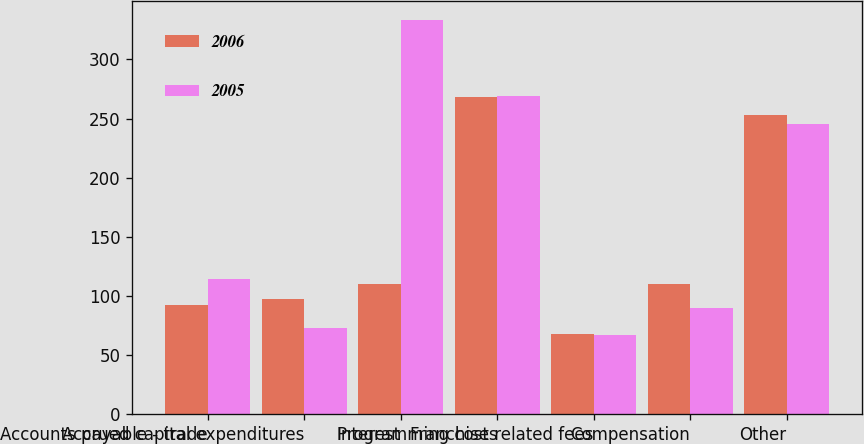<chart> <loc_0><loc_0><loc_500><loc_500><stacked_bar_chart><ecel><fcel>Accounts payable - trade<fcel>Accrued capital expenditures<fcel>Interest<fcel>Programming costs<fcel>Franchise related fees<fcel>Compensation<fcel>Other<nl><fcel>2006<fcel>92<fcel>97<fcel>110<fcel>268<fcel>68<fcel>110<fcel>253<nl><fcel>2005<fcel>114<fcel>73<fcel>333<fcel>269<fcel>67<fcel>90<fcel>245<nl></chart> 